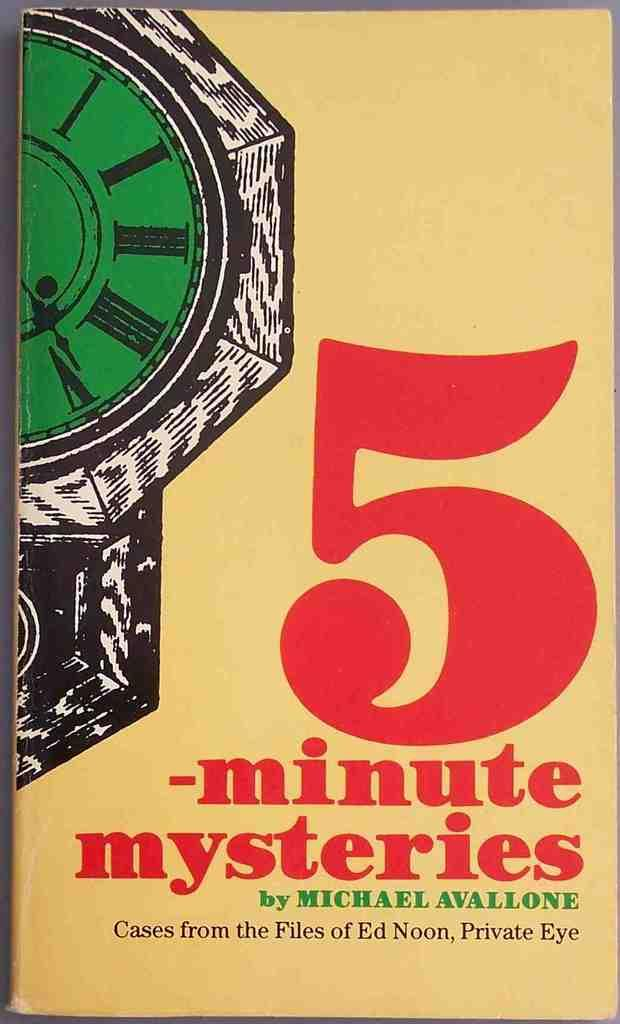<image>
Summarize the visual content of the image. The 5 minute mysteries series was written by Ed Noon. 